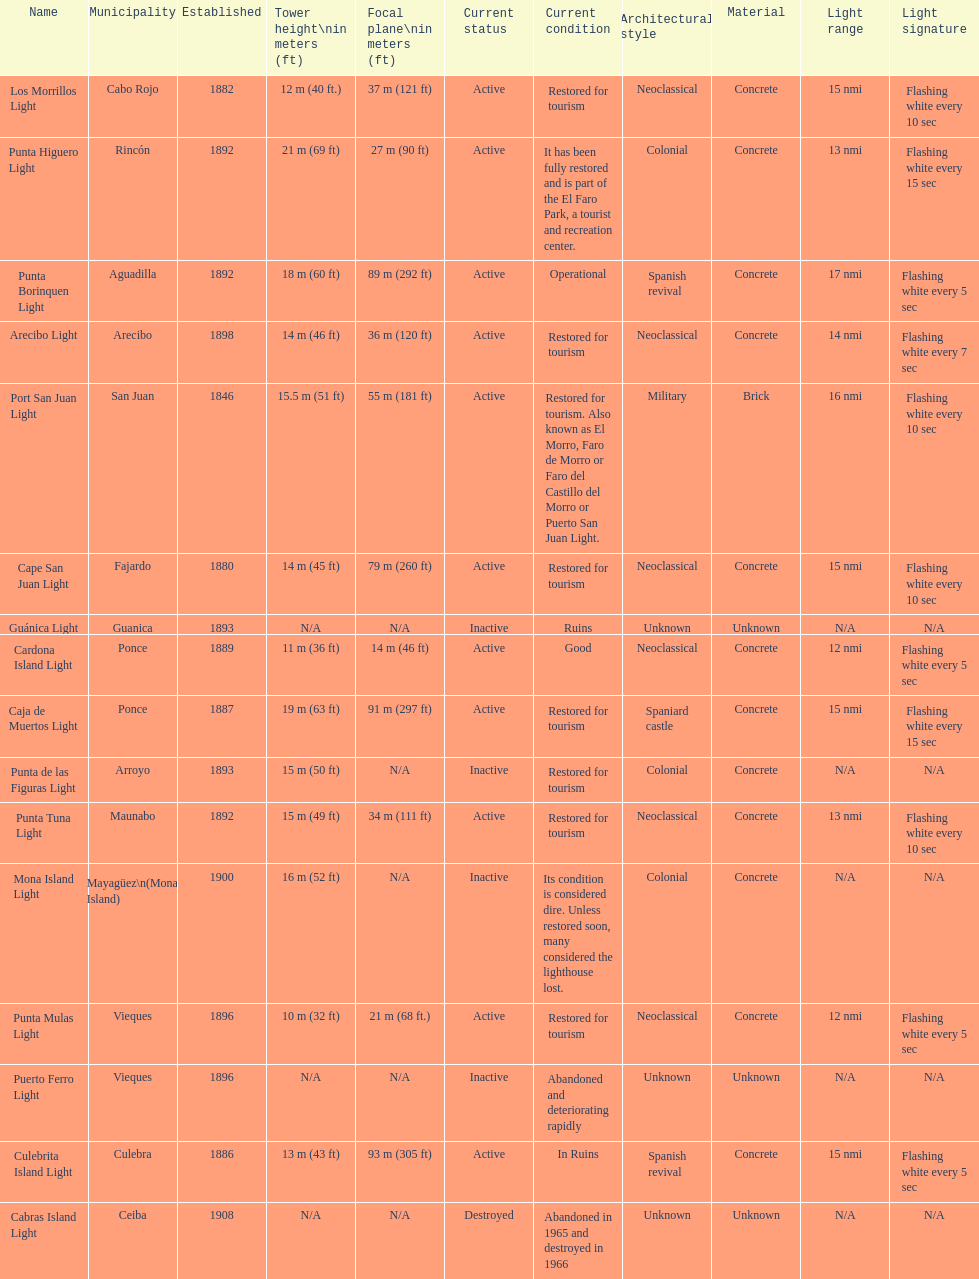What is the largest tower Punta Higuero Light. 